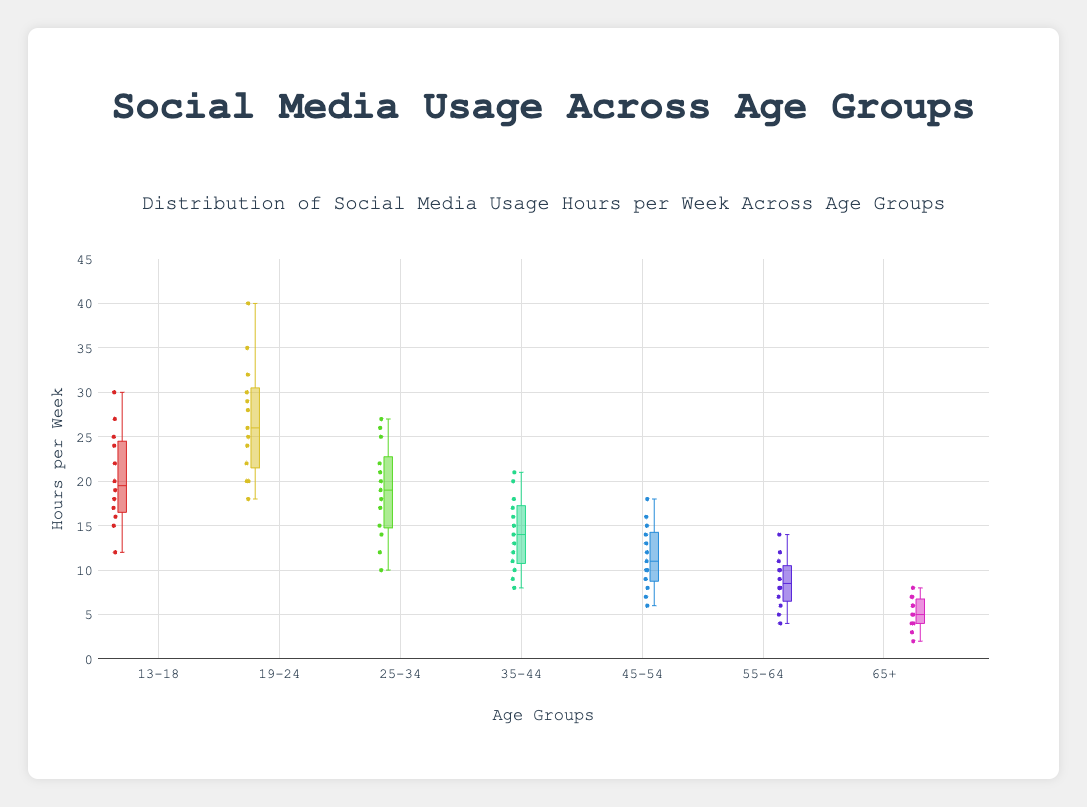What's the title of the figure? Look at the top of the figure where the title is displayed. It reads "Distribution of Social Media Usage Hours per Week Across Age Groups".
Answer: Distribution of Social Media Usage Hours per Week Across Age Groups What is the range of the y-axis? The y-axis represents the hours per week and its range spans from 0 to 45. This can be seen by observing the lowest and highest points on the y-axis.
Answer: 0 to 45 Which age group shows the highest median social media usage? In a box plot, the median is represented by the line inside the box. By comparing the medians across all age groups visually, the age group 19-24 has the highest median value.
Answer: 19-24 What is the interquartile range (IQR) for the 13-18 age group? The IQR is the difference between the third quartile (Q3) and the first quartile (Q1). For the 13-18 age group, Q3 appears to be around 24 hours, and Q1 appears to be around 17 hours. Therefore, IQR = Q3 - Q1 = 24 - 17 = 7 hours.
Answer: 7 hours Which age group has the largest spread in social media usage hours? The spread can be observed by the length of the box and the whiskers. The 19-24 age group has the largest spread, as its box and whiskers cover a wider range of hours compared to other groups.
Answer: 19-24 In which age group can we observe the lowest maximum value of social media usage? The maximum value can be identified from the top whisker of each box plot. The age group 65+ shows the lowest maximum value.
Answer: 65+ What is the median social media usage for the 55-64 age group? By looking at the line inside the box for the 55-64 age group, the median appears to be around 8 hours.
Answer: 8 hours How do the social media usage of the 35-44 and 45-54 age groups compare in terms of median usage? In the box plot, the medians are represented by the lines inside the boxes. The 35-44 age group has a slightly higher median than the 45-54 age group.
Answer: 35-44 is higher Provide the range (difference between maximum and minimum) of social media usage for the 25-34 age group. The range is found by subtracting the minimum value from the maximum value. For the 25-34 age group, the maximum value is around 27 hours and the minimum is around 10 hours. So, the range is 27 - 10 = 17 hours.
Answer: 17 hours 